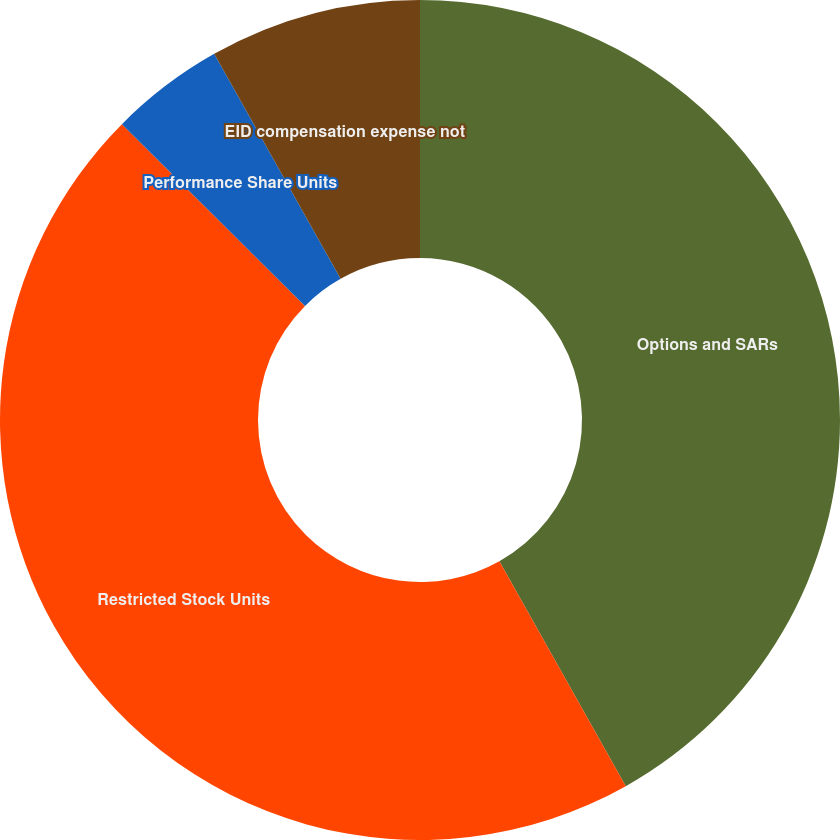<chart> <loc_0><loc_0><loc_500><loc_500><pie_chart><fcel>Options and SARs<fcel>Restricted Stock Units<fcel>Performance Share Units<fcel>EID compensation expense not<nl><fcel>41.85%<fcel>45.59%<fcel>4.41%<fcel>8.15%<nl></chart> 